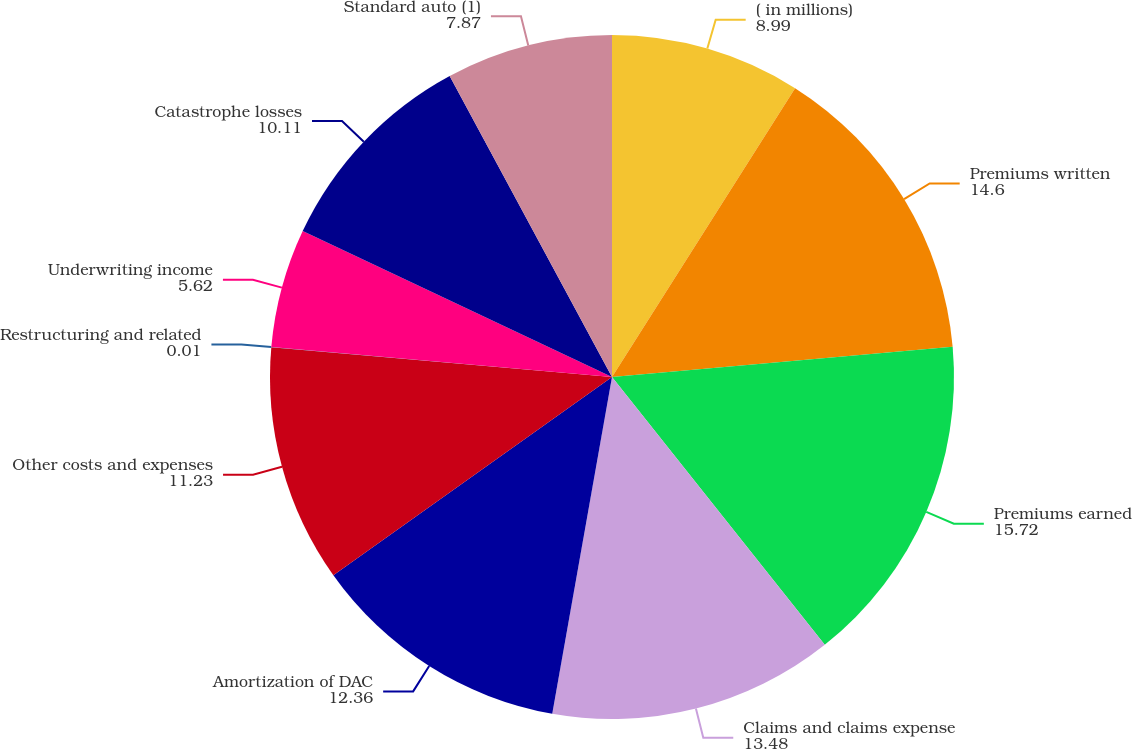Convert chart. <chart><loc_0><loc_0><loc_500><loc_500><pie_chart><fcel>( in millions)<fcel>Premiums written<fcel>Premiums earned<fcel>Claims and claims expense<fcel>Amortization of DAC<fcel>Other costs and expenses<fcel>Restructuring and related<fcel>Underwriting income<fcel>Catastrophe losses<fcel>Standard auto (1)<nl><fcel>8.99%<fcel>14.6%<fcel>15.72%<fcel>13.48%<fcel>12.36%<fcel>11.23%<fcel>0.01%<fcel>5.62%<fcel>10.11%<fcel>7.87%<nl></chart> 